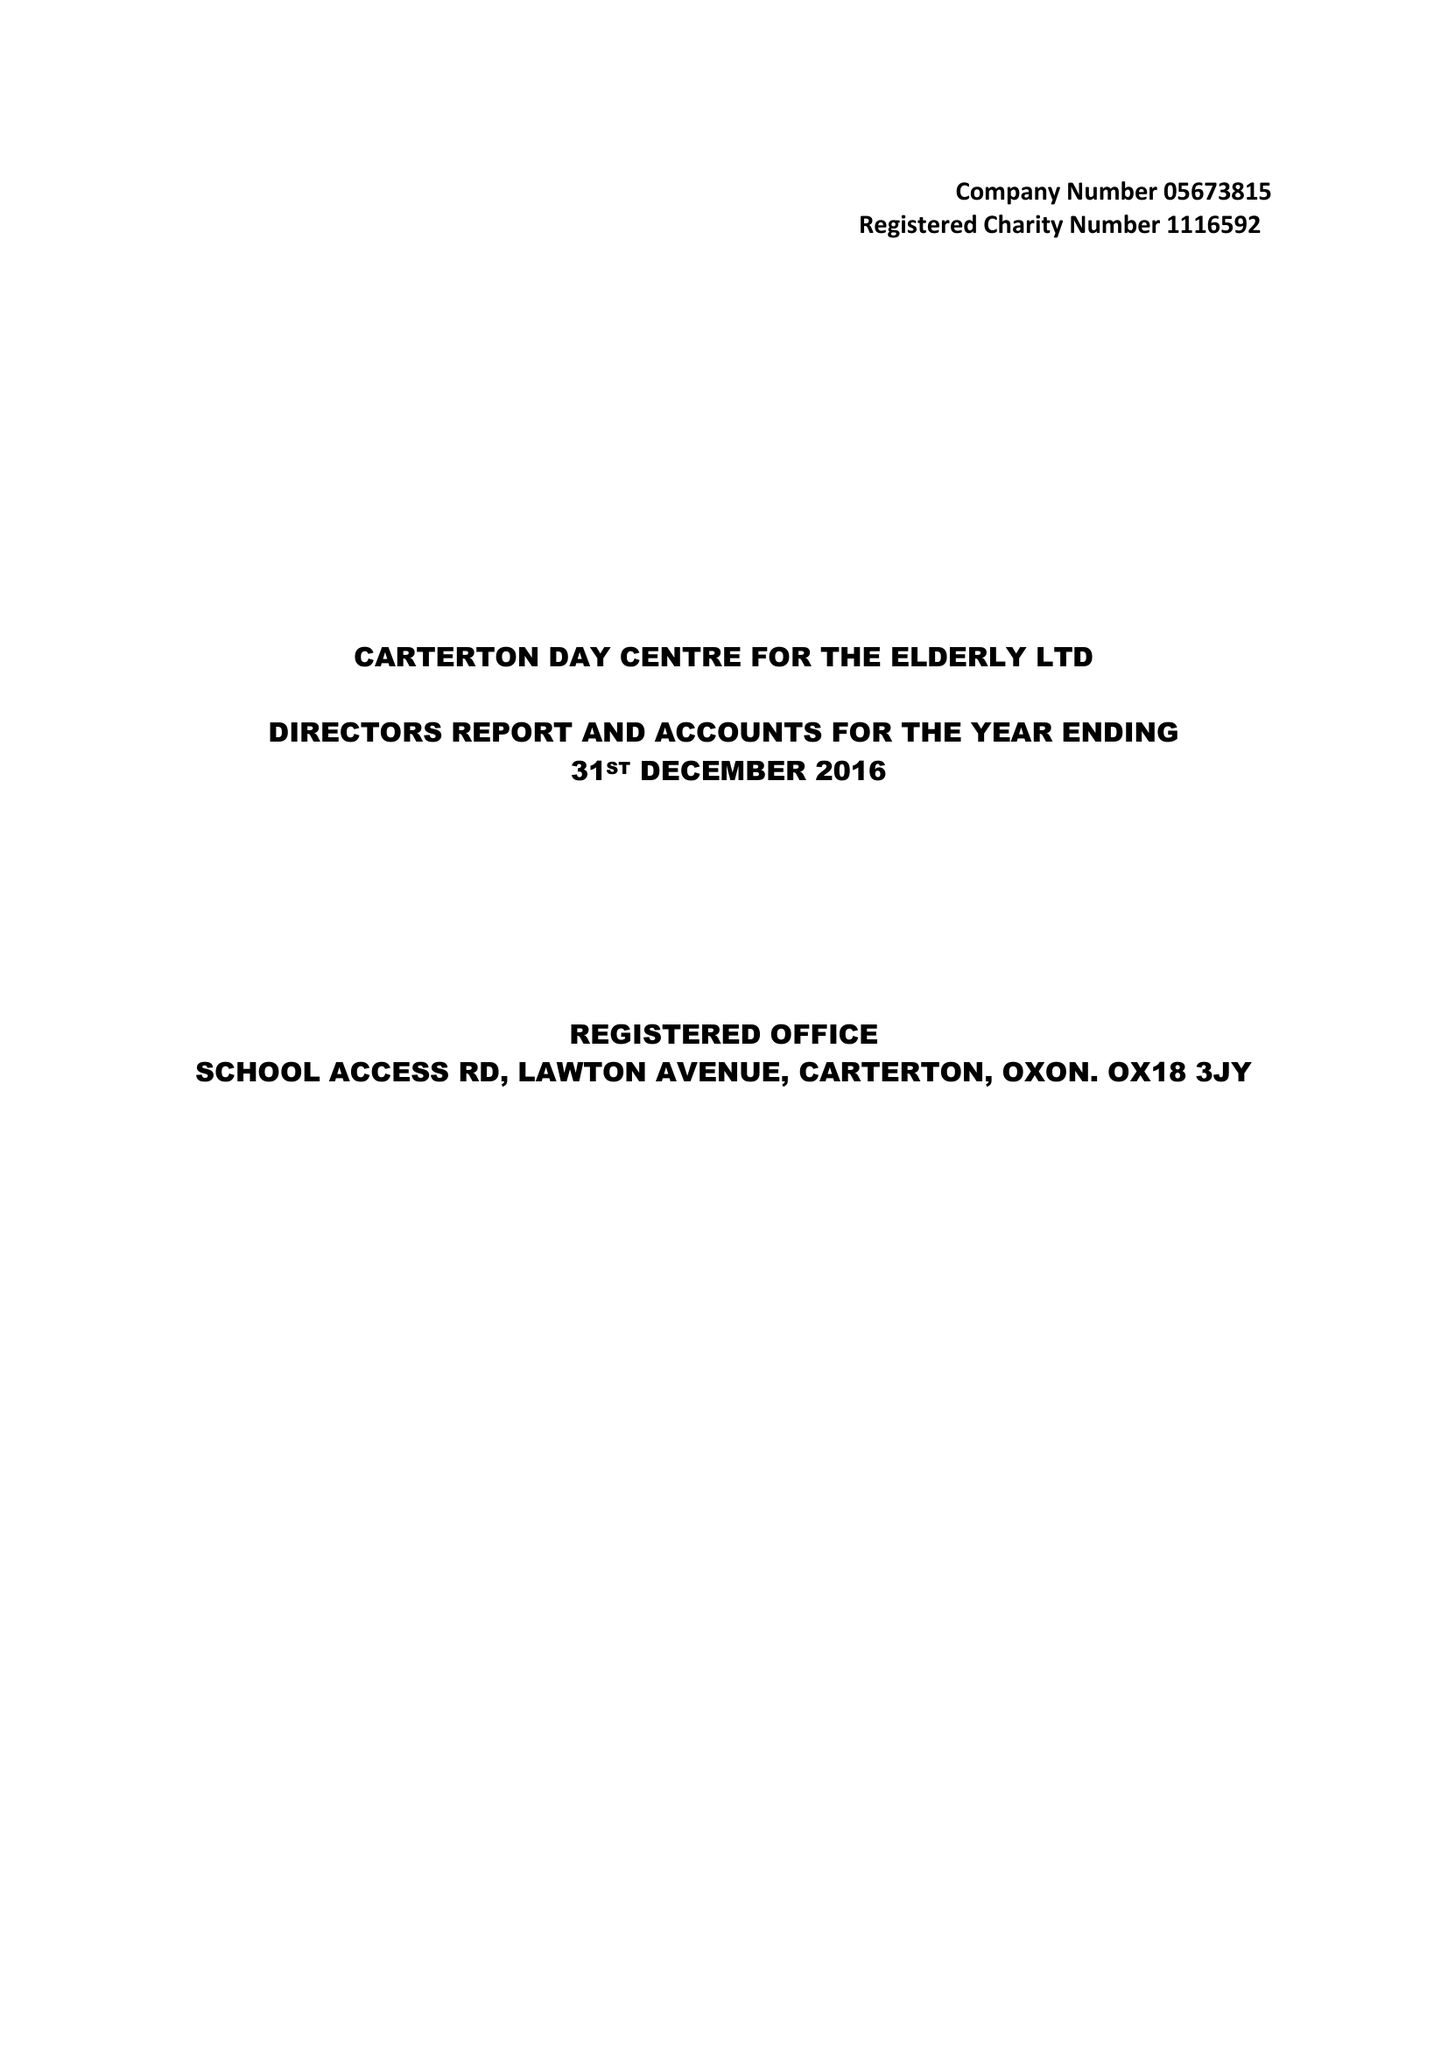What is the value for the charity_number?
Answer the question using a single word or phrase. 1116592 